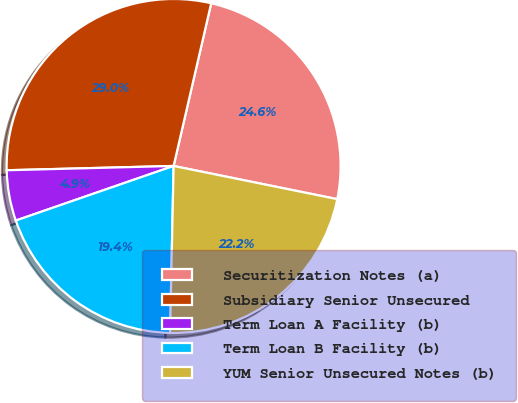Convert chart. <chart><loc_0><loc_0><loc_500><loc_500><pie_chart><fcel>Securitization Notes (a)<fcel>Subsidiary Senior Unsecured<fcel>Term Loan A Facility (b)<fcel>Term Loan B Facility (b)<fcel>YUM Senior Unsecured Notes (b)<nl><fcel>24.57%<fcel>29.02%<fcel>4.89%<fcel>19.36%<fcel>22.15%<nl></chart> 